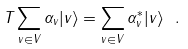Convert formula to latex. <formula><loc_0><loc_0><loc_500><loc_500>T \sum _ { v \in V } \alpha _ { v } | v \rangle = \sum _ { v \in V } \alpha ^ { * } _ { v } | v \rangle \ .</formula> 